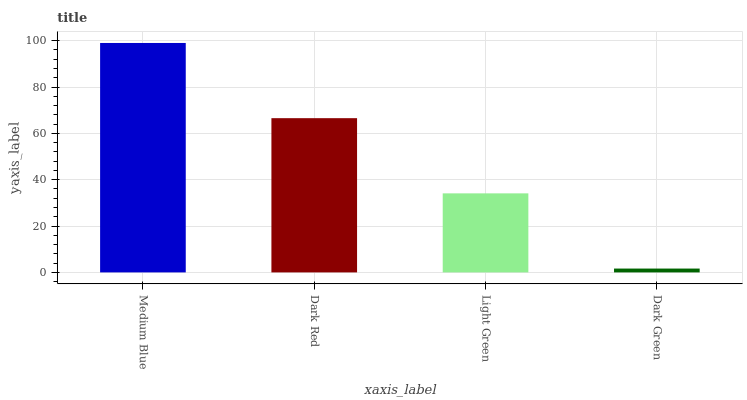Is Dark Green the minimum?
Answer yes or no. Yes. Is Medium Blue the maximum?
Answer yes or no. Yes. Is Dark Red the minimum?
Answer yes or no. No. Is Dark Red the maximum?
Answer yes or no. No. Is Medium Blue greater than Dark Red?
Answer yes or no. Yes. Is Dark Red less than Medium Blue?
Answer yes or no. Yes. Is Dark Red greater than Medium Blue?
Answer yes or no. No. Is Medium Blue less than Dark Red?
Answer yes or no. No. Is Dark Red the high median?
Answer yes or no. Yes. Is Light Green the low median?
Answer yes or no. Yes. Is Dark Green the high median?
Answer yes or no. No. Is Medium Blue the low median?
Answer yes or no. No. 